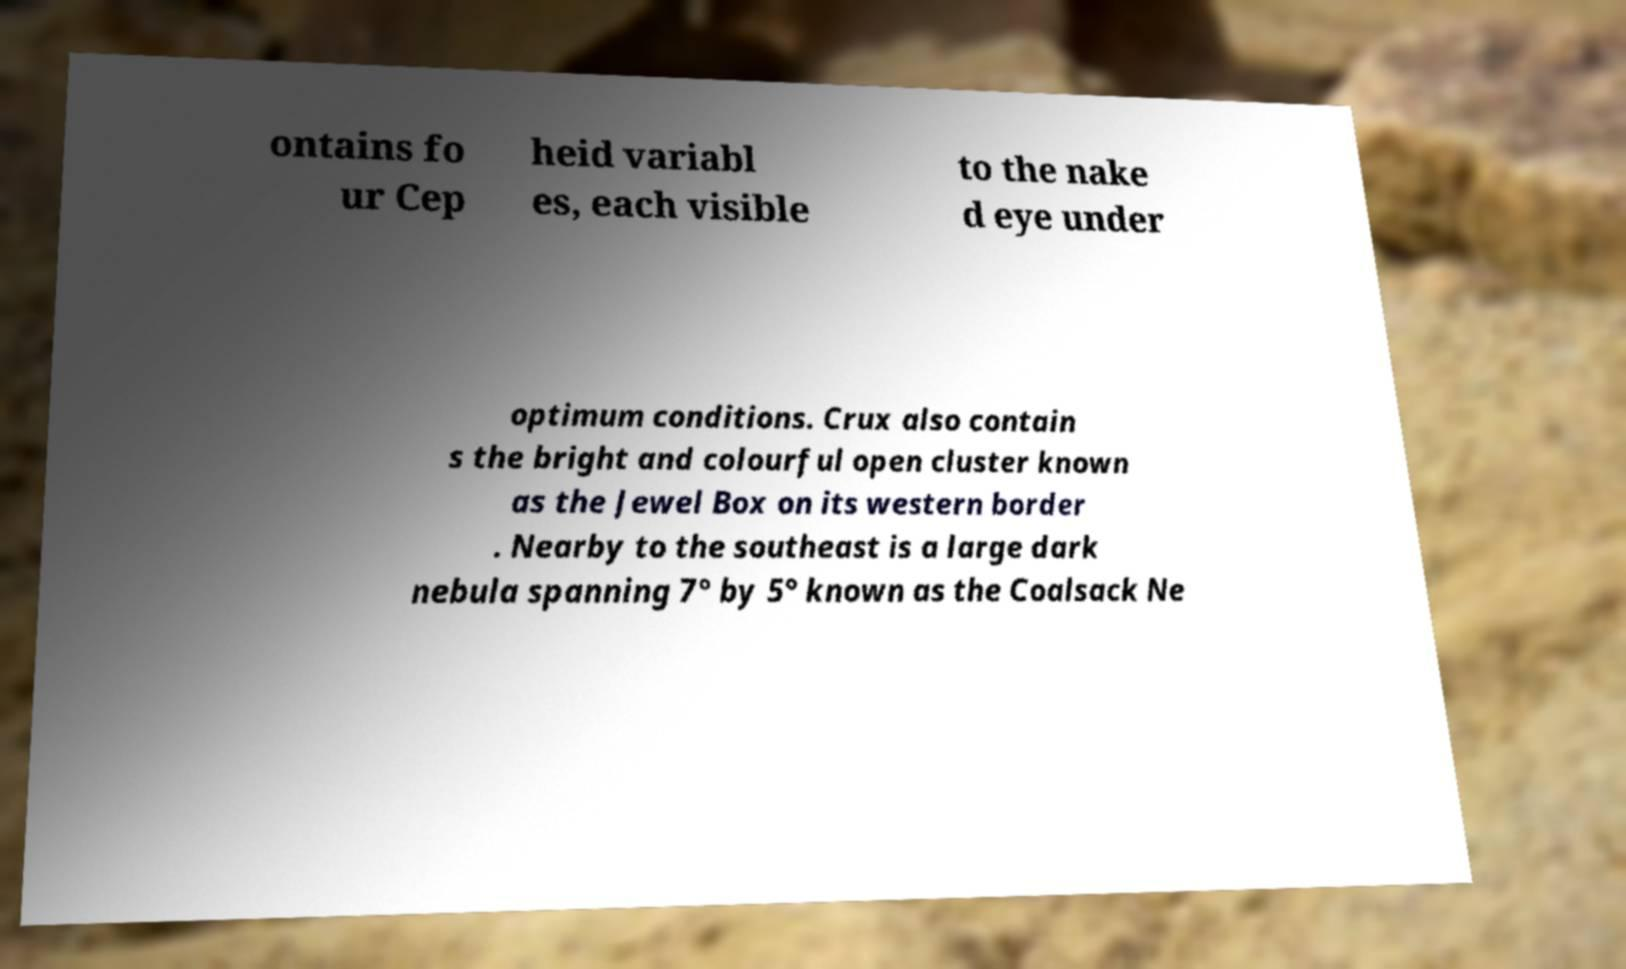Can you read and provide the text displayed in the image?This photo seems to have some interesting text. Can you extract and type it out for me? ontains fo ur Cep heid variabl es, each visible to the nake d eye under optimum conditions. Crux also contain s the bright and colourful open cluster known as the Jewel Box on its western border . Nearby to the southeast is a large dark nebula spanning 7° by 5° known as the Coalsack Ne 